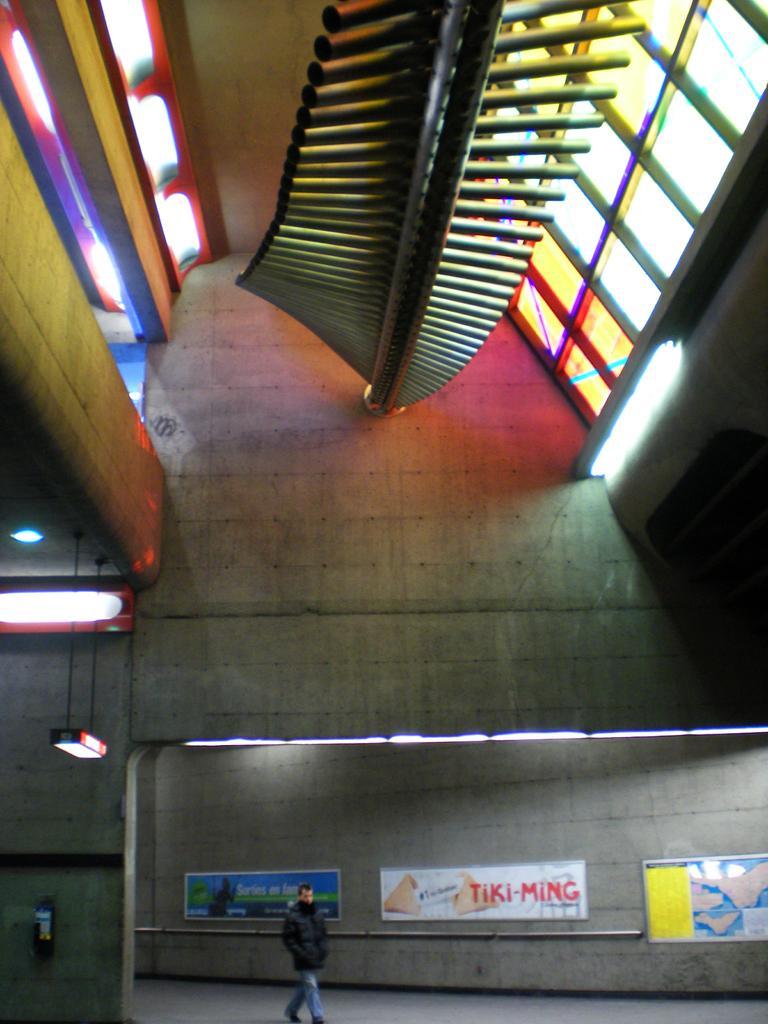Could you give a brief overview of what you see in this image? This is the picture of a building. In this image there is a person walking. At the back there are posters and there is a fire extinguisher on the wall. At the top there are lights. At the top there are mirrors on the roof. 